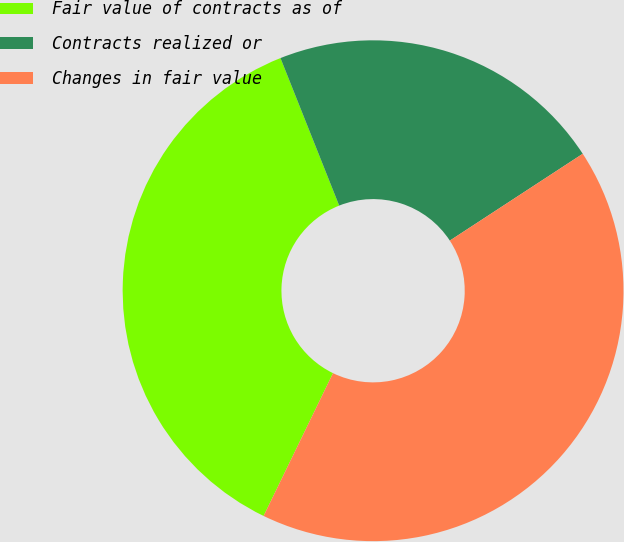Convert chart. <chart><loc_0><loc_0><loc_500><loc_500><pie_chart><fcel>Fair value of contracts as of<fcel>Contracts realized or<fcel>Changes in fair value<nl><fcel>36.77%<fcel>21.82%<fcel>41.41%<nl></chart> 